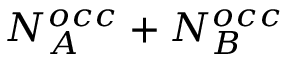Convert formula to latex. <formula><loc_0><loc_0><loc_500><loc_500>N _ { A } ^ { o c c } + N _ { B } ^ { o c c }</formula> 